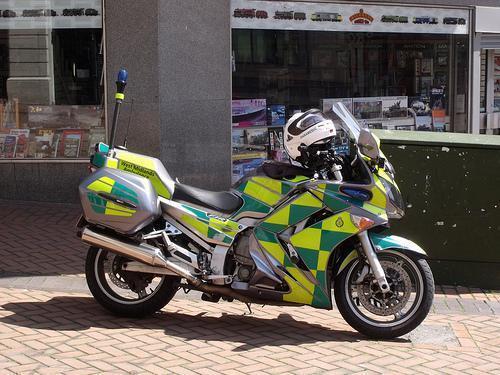How many motorcycles are there?
Give a very brief answer. 1. 